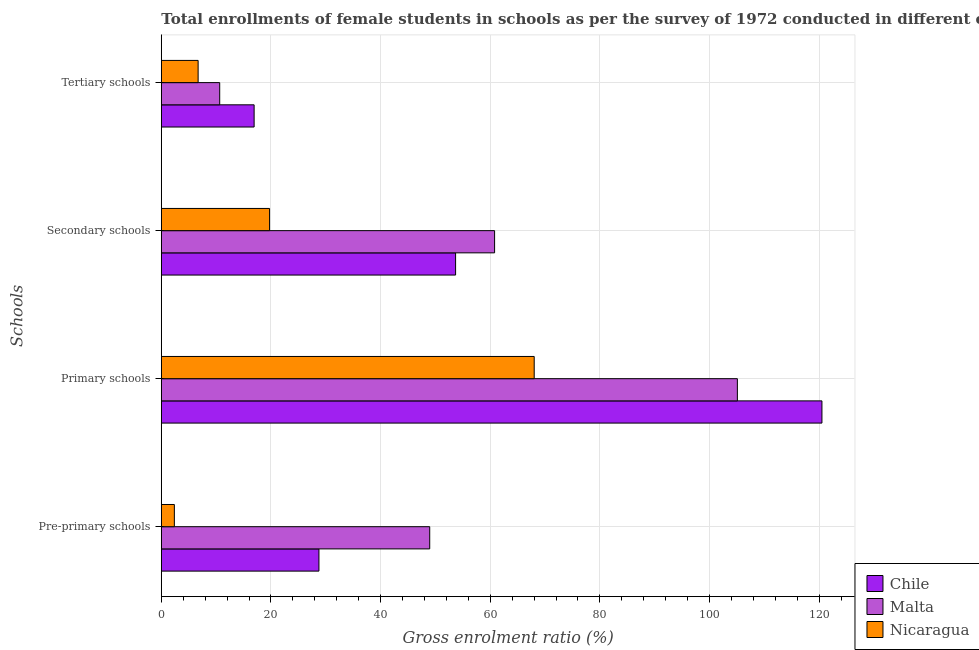How many groups of bars are there?
Your answer should be very brief. 4. How many bars are there on the 3rd tick from the top?
Make the answer very short. 3. What is the label of the 3rd group of bars from the top?
Make the answer very short. Primary schools. What is the gross enrolment ratio(female) in secondary schools in Chile?
Offer a very short reply. 53.68. Across all countries, what is the maximum gross enrolment ratio(female) in tertiary schools?
Make the answer very short. 16.93. Across all countries, what is the minimum gross enrolment ratio(female) in pre-primary schools?
Offer a terse response. 2.38. In which country was the gross enrolment ratio(female) in pre-primary schools maximum?
Offer a terse response. Malta. In which country was the gross enrolment ratio(female) in primary schools minimum?
Provide a short and direct response. Nicaragua. What is the total gross enrolment ratio(female) in tertiary schools in the graph?
Your answer should be very brief. 34.3. What is the difference between the gross enrolment ratio(female) in pre-primary schools in Nicaragua and that in Malta?
Your answer should be very brief. -46.58. What is the difference between the gross enrolment ratio(female) in pre-primary schools in Chile and the gross enrolment ratio(female) in tertiary schools in Malta?
Offer a very short reply. 18.1. What is the average gross enrolment ratio(female) in pre-primary schools per country?
Ensure brevity in your answer.  26.7. What is the difference between the gross enrolment ratio(female) in tertiary schools and gross enrolment ratio(female) in pre-primary schools in Chile?
Provide a short and direct response. -11.82. In how many countries, is the gross enrolment ratio(female) in pre-primary schools greater than 20 %?
Keep it short and to the point. 2. What is the ratio of the gross enrolment ratio(female) in tertiary schools in Nicaragua to that in Chile?
Offer a terse response. 0.4. Is the gross enrolment ratio(female) in pre-primary schools in Nicaragua less than that in Malta?
Your answer should be very brief. Yes. What is the difference between the highest and the second highest gross enrolment ratio(female) in secondary schools?
Offer a terse response. 7.11. What is the difference between the highest and the lowest gross enrolment ratio(female) in tertiary schools?
Keep it short and to the point. 10.22. In how many countries, is the gross enrolment ratio(female) in pre-primary schools greater than the average gross enrolment ratio(female) in pre-primary schools taken over all countries?
Offer a terse response. 2. Is it the case that in every country, the sum of the gross enrolment ratio(female) in primary schools and gross enrolment ratio(female) in secondary schools is greater than the sum of gross enrolment ratio(female) in tertiary schools and gross enrolment ratio(female) in pre-primary schools?
Offer a very short reply. No. What does the 2nd bar from the top in Primary schools represents?
Your answer should be compact. Malta. What does the 3rd bar from the bottom in Primary schools represents?
Keep it short and to the point. Nicaragua. Is it the case that in every country, the sum of the gross enrolment ratio(female) in pre-primary schools and gross enrolment ratio(female) in primary schools is greater than the gross enrolment ratio(female) in secondary schools?
Give a very brief answer. Yes. How many bars are there?
Ensure brevity in your answer.  12. How many countries are there in the graph?
Provide a succinct answer. 3. What is the difference between two consecutive major ticks on the X-axis?
Offer a very short reply. 20. Are the values on the major ticks of X-axis written in scientific E-notation?
Offer a terse response. No. Does the graph contain grids?
Provide a succinct answer. Yes. How many legend labels are there?
Offer a terse response. 3. What is the title of the graph?
Offer a very short reply. Total enrollments of female students in schools as per the survey of 1972 conducted in different countries. What is the label or title of the Y-axis?
Your answer should be compact. Schools. What is the Gross enrolment ratio (%) in Chile in Pre-primary schools?
Offer a very short reply. 28.75. What is the Gross enrolment ratio (%) in Malta in Pre-primary schools?
Make the answer very short. 48.96. What is the Gross enrolment ratio (%) in Nicaragua in Pre-primary schools?
Offer a very short reply. 2.38. What is the Gross enrolment ratio (%) in Chile in Primary schools?
Your response must be concise. 120.51. What is the Gross enrolment ratio (%) of Malta in Primary schools?
Provide a short and direct response. 105.09. What is the Gross enrolment ratio (%) of Nicaragua in Primary schools?
Your answer should be very brief. 68.02. What is the Gross enrolment ratio (%) of Chile in Secondary schools?
Your response must be concise. 53.68. What is the Gross enrolment ratio (%) of Malta in Secondary schools?
Offer a very short reply. 60.8. What is the Gross enrolment ratio (%) in Nicaragua in Secondary schools?
Provide a succinct answer. 19.75. What is the Gross enrolment ratio (%) in Chile in Tertiary schools?
Provide a succinct answer. 16.93. What is the Gross enrolment ratio (%) of Malta in Tertiary schools?
Offer a terse response. 10.65. What is the Gross enrolment ratio (%) of Nicaragua in Tertiary schools?
Your answer should be very brief. 6.72. Across all Schools, what is the maximum Gross enrolment ratio (%) of Chile?
Ensure brevity in your answer.  120.51. Across all Schools, what is the maximum Gross enrolment ratio (%) in Malta?
Your answer should be compact. 105.09. Across all Schools, what is the maximum Gross enrolment ratio (%) in Nicaragua?
Your answer should be very brief. 68.02. Across all Schools, what is the minimum Gross enrolment ratio (%) in Chile?
Keep it short and to the point. 16.93. Across all Schools, what is the minimum Gross enrolment ratio (%) of Malta?
Make the answer very short. 10.65. Across all Schools, what is the minimum Gross enrolment ratio (%) of Nicaragua?
Give a very brief answer. 2.38. What is the total Gross enrolment ratio (%) in Chile in the graph?
Ensure brevity in your answer.  219.88. What is the total Gross enrolment ratio (%) of Malta in the graph?
Make the answer very short. 225.5. What is the total Gross enrolment ratio (%) in Nicaragua in the graph?
Your answer should be compact. 96.87. What is the difference between the Gross enrolment ratio (%) of Chile in Pre-primary schools and that in Primary schools?
Your answer should be compact. -91.76. What is the difference between the Gross enrolment ratio (%) of Malta in Pre-primary schools and that in Primary schools?
Provide a short and direct response. -56.12. What is the difference between the Gross enrolment ratio (%) in Nicaragua in Pre-primary schools and that in Primary schools?
Your response must be concise. -65.64. What is the difference between the Gross enrolment ratio (%) in Chile in Pre-primary schools and that in Secondary schools?
Your answer should be compact. -24.93. What is the difference between the Gross enrolment ratio (%) of Malta in Pre-primary schools and that in Secondary schools?
Offer a terse response. -11.83. What is the difference between the Gross enrolment ratio (%) in Nicaragua in Pre-primary schools and that in Secondary schools?
Offer a very short reply. -17.37. What is the difference between the Gross enrolment ratio (%) of Chile in Pre-primary schools and that in Tertiary schools?
Provide a short and direct response. 11.82. What is the difference between the Gross enrolment ratio (%) in Malta in Pre-primary schools and that in Tertiary schools?
Your answer should be very brief. 38.31. What is the difference between the Gross enrolment ratio (%) in Nicaragua in Pre-primary schools and that in Tertiary schools?
Offer a very short reply. -4.34. What is the difference between the Gross enrolment ratio (%) in Chile in Primary schools and that in Secondary schools?
Give a very brief answer. 66.83. What is the difference between the Gross enrolment ratio (%) of Malta in Primary schools and that in Secondary schools?
Provide a succinct answer. 44.29. What is the difference between the Gross enrolment ratio (%) in Nicaragua in Primary schools and that in Secondary schools?
Your response must be concise. 48.28. What is the difference between the Gross enrolment ratio (%) in Chile in Primary schools and that in Tertiary schools?
Ensure brevity in your answer.  103.58. What is the difference between the Gross enrolment ratio (%) of Malta in Primary schools and that in Tertiary schools?
Your response must be concise. 94.44. What is the difference between the Gross enrolment ratio (%) in Nicaragua in Primary schools and that in Tertiary schools?
Provide a short and direct response. 61.31. What is the difference between the Gross enrolment ratio (%) in Chile in Secondary schools and that in Tertiary schools?
Provide a succinct answer. 36.75. What is the difference between the Gross enrolment ratio (%) in Malta in Secondary schools and that in Tertiary schools?
Your answer should be compact. 50.15. What is the difference between the Gross enrolment ratio (%) in Nicaragua in Secondary schools and that in Tertiary schools?
Ensure brevity in your answer.  13.03. What is the difference between the Gross enrolment ratio (%) of Chile in Pre-primary schools and the Gross enrolment ratio (%) of Malta in Primary schools?
Your answer should be very brief. -76.33. What is the difference between the Gross enrolment ratio (%) of Chile in Pre-primary schools and the Gross enrolment ratio (%) of Nicaragua in Primary schools?
Keep it short and to the point. -39.27. What is the difference between the Gross enrolment ratio (%) in Malta in Pre-primary schools and the Gross enrolment ratio (%) in Nicaragua in Primary schools?
Keep it short and to the point. -19.06. What is the difference between the Gross enrolment ratio (%) of Chile in Pre-primary schools and the Gross enrolment ratio (%) of Malta in Secondary schools?
Make the answer very short. -32.05. What is the difference between the Gross enrolment ratio (%) of Chile in Pre-primary schools and the Gross enrolment ratio (%) of Nicaragua in Secondary schools?
Your response must be concise. 9.01. What is the difference between the Gross enrolment ratio (%) of Malta in Pre-primary schools and the Gross enrolment ratio (%) of Nicaragua in Secondary schools?
Provide a short and direct response. 29.22. What is the difference between the Gross enrolment ratio (%) of Chile in Pre-primary schools and the Gross enrolment ratio (%) of Malta in Tertiary schools?
Your response must be concise. 18.1. What is the difference between the Gross enrolment ratio (%) of Chile in Pre-primary schools and the Gross enrolment ratio (%) of Nicaragua in Tertiary schools?
Provide a short and direct response. 22.04. What is the difference between the Gross enrolment ratio (%) of Malta in Pre-primary schools and the Gross enrolment ratio (%) of Nicaragua in Tertiary schools?
Give a very brief answer. 42.25. What is the difference between the Gross enrolment ratio (%) in Chile in Primary schools and the Gross enrolment ratio (%) in Malta in Secondary schools?
Make the answer very short. 59.71. What is the difference between the Gross enrolment ratio (%) in Chile in Primary schools and the Gross enrolment ratio (%) in Nicaragua in Secondary schools?
Keep it short and to the point. 100.77. What is the difference between the Gross enrolment ratio (%) in Malta in Primary schools and the Gross enrolment ratio (%) in Nicaragua in Secondary schools?
Offer a very short reply. 85.34. What is the difference between the Gross enrolment ratio (%) of Chile in Primary schools and the Gross enrolment ratio (%) of Malta in Tertiary schools?
Make the answer very short. 109.86. What is the difference between the Gross enrolment ratio (%) of Chile in Primary schools and the Gross enrolment ratio (%) of Nicaragua in Tertiary schools?
Your answer should be very brief. 113.8. What is the difference between the Gross enrolment ratio (%) in Malta in Primary schools and the Gross enrolment ratio (%) in Nicaragua in Tertiary schools?
Provide a succinct answer. 98.37. What is the difference between the Gross enrolment ratio (%) in Chile in Secondary schools and the Gross enrolment ratio (%) in Malta in Tertiary schools?
Offer a very short reply. 43.03. What is the difference between the Gross enrolment ratio (%) of Chile in Secondary schools and the Gross enrolment ratio (%) of Nicaragua in Tertiary schools?
Provide a short and direct response. 46.97. What is the difference between the Gross enrolment ratio (%) in Malta in Secondary schools and the Gross enrolment ratio (%) in Nicaragua in Tertiary schools?
Provide a short and direct response. 54.08. What is the average Gross enrolment ratio (%) of Chile per Schools?
Your response must be concise. 54.97. What is the average Gross enrolment ratio (%) in Malta per Schools?
Provide a succinct answer. 56.38. What is the average Gross enrolment ratio (%) in Nicaragua per Schools?
Give a very brief answer. 24.22. What is the difference between the Gross enrolment ratio (%) in Chile and Gross enrolment ratio (%) in Malta in Pre-primary schools?
Keep it short and to the point. -20.21. What is the difference between the Gross enrolment ratio (%) in Chile and Gross enrolment ratio (%) in Nicaragua in Pre-primary schools?
Give a very brief answer. 26.37. What is the difference between the Gross enrolment ratio (%) of Malta and Gross enrolment ratio (%) of Nicaragua in Pre-primary schools?
Provide a short and direct response. 46.58. What is the difference between the Gross enrolment ratio (%) of Chile and Gross enrolment ratio (%) of Malta in Primary schools?
Your answer should be very brief. 15.43. What is the difference between the Gross enrolment ratio (%) of Chile and Gross enrolment ratio (%) of Nicaragua in Primary schools?
Give a very brief answer. 52.49. What is the difference between the Gross enrolment ratio (%) in Malta and Gross enrolment ratio (%) in Nicaragua in Primary schools?
Provide a succinct answer. 37.06. What is the difference between the Gross enrolment ratio (%) of Chile and Gross enrolment ratio (%) of Malta in Secondary schools?
Provide a succinct answer. -7.11. What is the difference between the Gross enrolment ratio (%) of Chile and Gross enrolment ratio (%) of Nicaragua in Secondary schools?
Ensure brevity in your answer.  33.94. What is the difference between the Gross enrolment ratio (%) in Malta and Gross enrolment ratio (%) in Nicaragua in Secondary schools?
Keep it short and to the point. 41.05. What is the difference between the Gross enrolment ratio (%) in Chile and Gross enrolment ratio (%) in Malta in Tertiary schools?
Offer a very short reply. 6.28. What is the difference between the Gross enrolment ratio (%) of Chile and Gross enrolment ratio (%) of Nicaragua in Tertiary schools?
Ensure brevity in your answer.  10.22. What is the difference between the Gross enrolment ratio (%) of Malta and Gross enrolment ratio (%) of Nicaragua in Tertiary schools?
Your answer should be very brief. 3.94. What is the ratio of the Gross enrolment ratio (%) in Chile in Pre-primary schools to that in Primary schools?
Give a very brief answer. 0.24. What is the ratio of the Gross enrolment ratio (%) of Malta in Pre-primary schools to that in Primary schools?
Give a very brief answer. 0.47. What is the ratio of the Gross enrolment ratio (%) in Nicaragua in Pre-primary schools to that in Primary schools?
Make the answer very short. 0.04. What is the ratio of the Gross enrolment ratio (%) in Chile in Pre-primary schools to that in Secondary schools?
Your answer should be very brief. 0.54. What is the ratio of the Gross enrolment ratio (%) of Malta in Pre-primary schools to that in Secondary schools?
Offer a very short reply. 0.81. What is the ratio of the Gross enrolment ratio (%) of Nicaragua in Pre-primary schools to that in Secondary schools?
Make the answer very short. 0.12. What is the ratio of the Gross enrolment ratio (%) in Chile in Pre-primary schools to that in Tertiary schools?
Your answer should be compact. 1.7. What is the ratio of the Gross enrolment ratio (%) in Malta in Pre-primary schools to that in Tertiary schools?
Provide a short and direct response. 4.6. What is the ratio of the Gross enrolment ratio (%) of Nicaragua in Pre-primary schools to that in Tertiary schools?
Offer a very short reply. 0.35. What is the ratio of the Gross enrolment ratio (%) of Chile in Primary schools to that in Secondary schools?
Offer a terse response. 2.24. What is the ratio of the Gross enrolment ratio (%) of Malta in Primary schools to that in Secondary schools?
Ensure brevity in your answer.  1.73. What is the ratio of the Gross enrolment ratio (%) of Nicaragua in Primary schools to that in Secondary schools?
Ensure brevity in your answer.  3.44. What is the ratio of the Gross enrolment ratio (%) in Chile in Primary schools to that in Tertiary schools?
Keep it short and to the point. 7.12. What is the ratio of the Gross enrolment ratio (%) in Malta in Primary schools to that in Tertiary schools?
Offer a very short reply. 9.87. What is the ratio of the Gross enrolment ratio (%) in Nicaragua in Primary schools to that in Tertiary schools?
Keep it short and to the point. 10.13. What is the ratio of the Gross enrolment ratio (%) in Chile in Secondary schools to that in Tertiary schools?
Your response must be concise. 3.17. What is the ratio of the Gross enrolment ratio (%) of Malta in Secondary schools to that in Tertiary schools?
Offer a very short reply. 5.71. What is the ratio of the Gross enrolment ratio (%) in Nicaragua in Secondary schools to that in Tertiary schools?
Offer a very short reply. 2.94. What is the difference between the highest and the second highest Gross enrolment ratio (%) in Chile?
Make the answer very short. 66.83. What is the difference between the highest and the second highest Gross enrolment ratio (%) of Malta?
Provide a succinct answer. 44.29. What is the difference between the highest and the second highest Gross enrolment ratio (%) in Nicaragua?
Provide a succinct answer. 48.28. What is the difference between the highest and the lowest Gross enrolment ratio (%) of Chile?
Make the answer very short. 103.58. What is the difference between the highest and the lowest Gross enrolment ratio (%) in Malta?
Offer a terse response. 94.44. What is the difference between the highest and the lowest Gross enrolment ratio (%) of Nicaragua?
Your answer should be very brief. 65.64. 